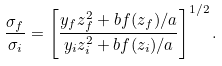<formula> <loc_0><loc_0><loc_500><loc_500>\frac { \sigma _ { f } } { \sigma _ { i } } = \left [ \frac { y _ { f } z _ { f } ^ { 2 } + b f ( z _ { f } ) / a } { y _ { i } z _ { i } ^ { 2 } + b f ( z _ { i } ) / a } \right ] ^ { 1 / 2 } .</formula> 